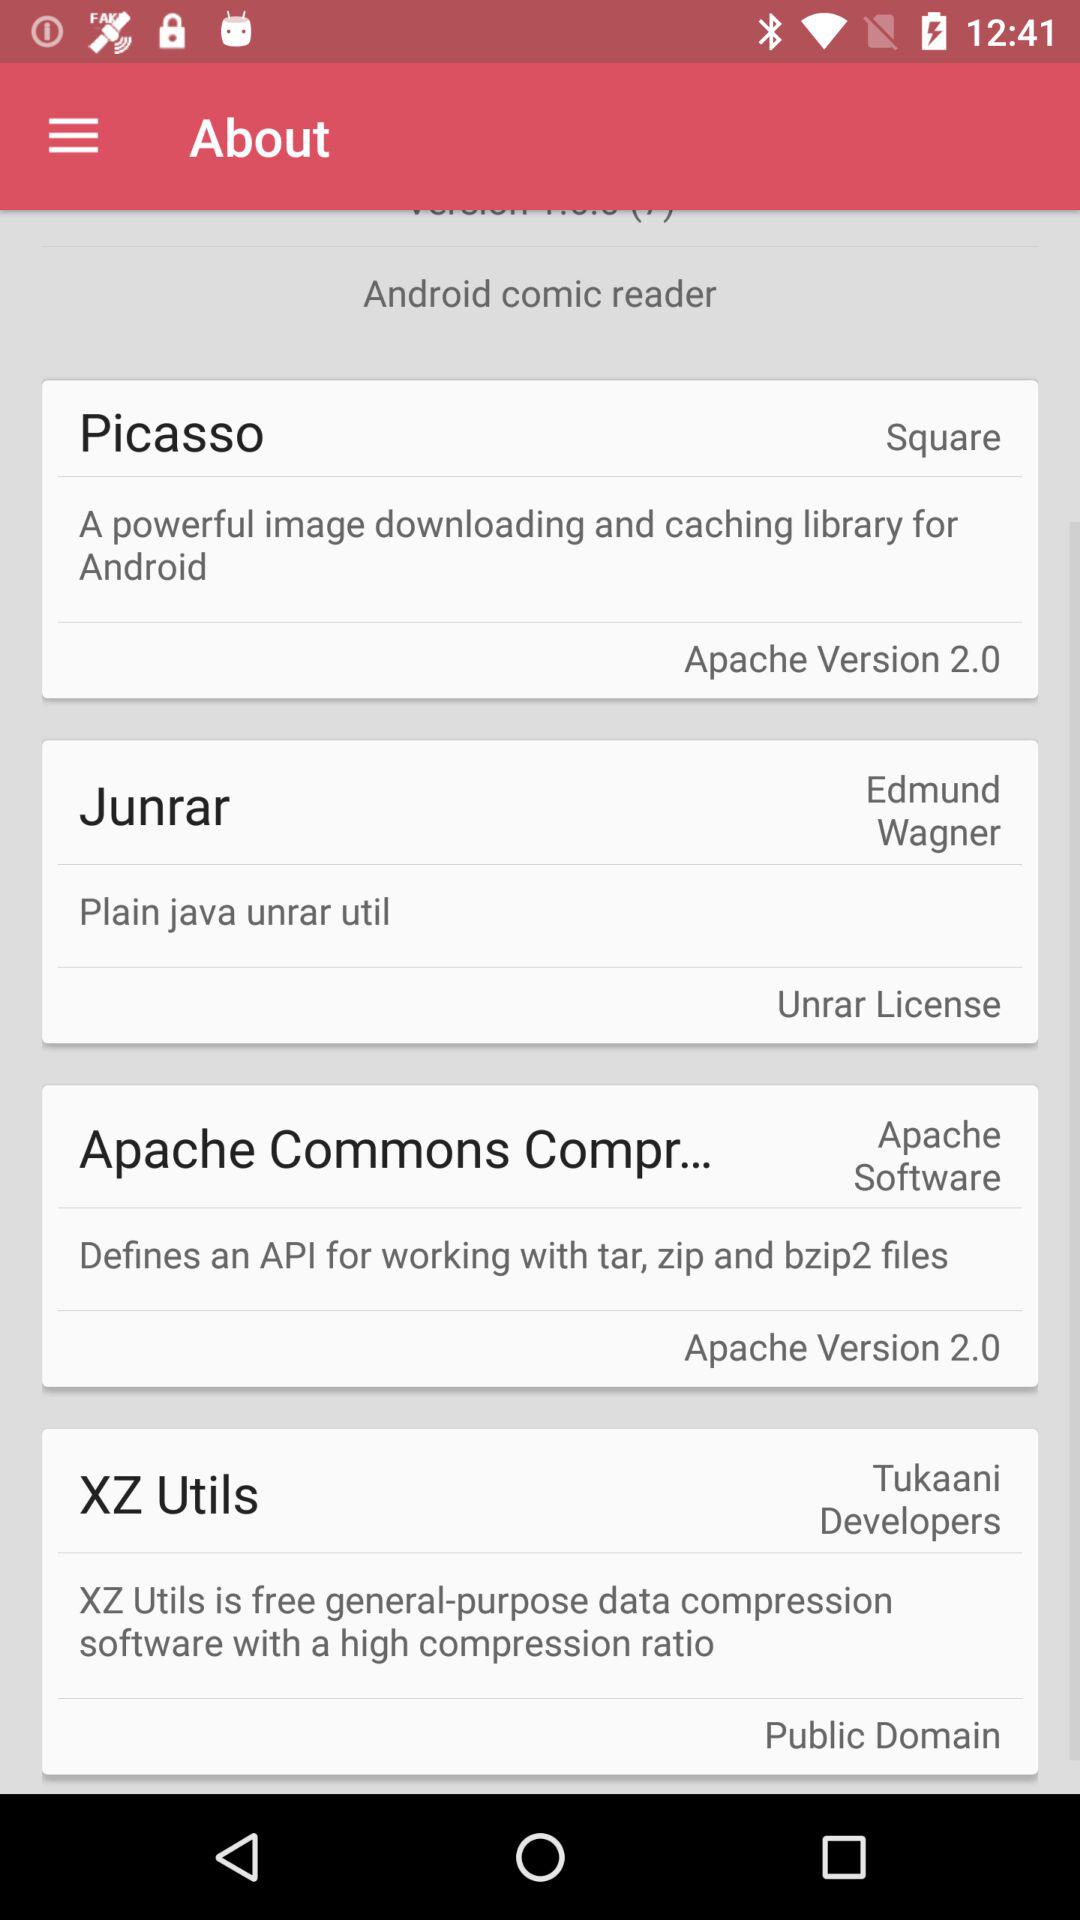Which version of the application is this?
When the provided information is insufficient, respond with <no answer>. <no answer> 